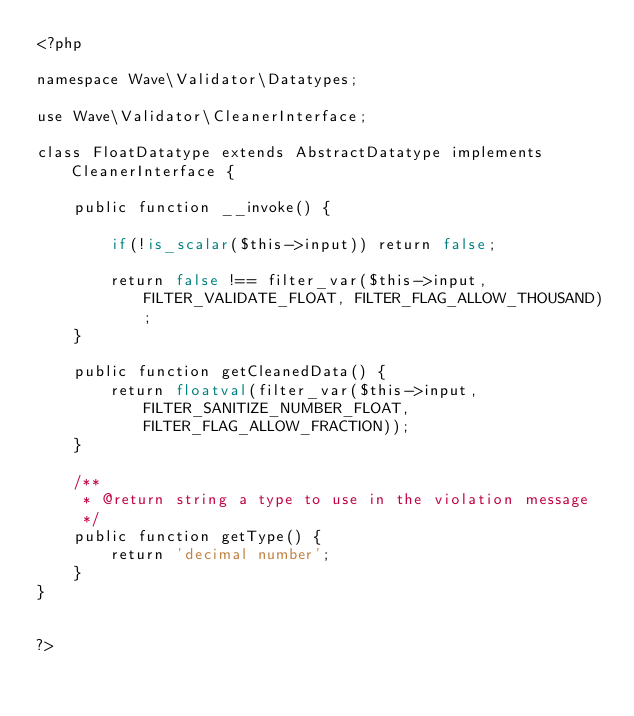<code> <loc_0><loc_0><loc_500><loc_500><_PHP_><?php

namespace Wave\Validator\Datatypes;

use Wave\Validator\CleanerInterface;

class FloatDatatype extends AbstractDatatype implements CleanerInterface {

    public function __invoke() {

        if(!is_scalar($this->input)) return false;

        return false !== filter_var($this->input, FILTER_VALIDATE_FLOAT, FILTER_FLAG_ALLOW_THOUSAND);
    }

    public function getCleanedData() {
        return floatval(filter_var($this->input, FILTER_SANITIZE_NUMBER_FLOAT, FILTER_FLAG_ALLOW_FRACTION));
    }

    /**
     * @return string a type to use in the violation message
     */
    public function getType() {
        return 'decimal number';
    }
}


?></code> 